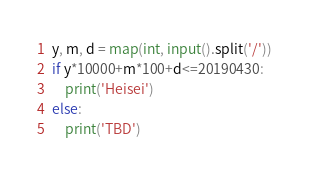Convert code to text. <code><loc_0><loc_0><loc_500><loc_500><_Python_>y, m, d = map(int, input().split('/'))
if y*10000+m*100+d<=20190430:
	print('Heisei')
else:
	print('TBD')

</code> 